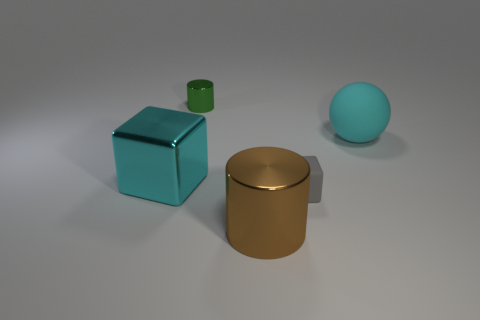Add 5 large brown objects. How many objects exist? 10 Subtract all spheres. How many objects are left? 4 Add 1 small green metal objects. How many small green metal objects are left? 2 Add 5 yellow matte things. How many yellow matte things exist? 5 Subtract 0 purple cylinders. How many objects are left? 5 Subtract all blocks. Subtract all small rubber things. How many objects are left? 2 